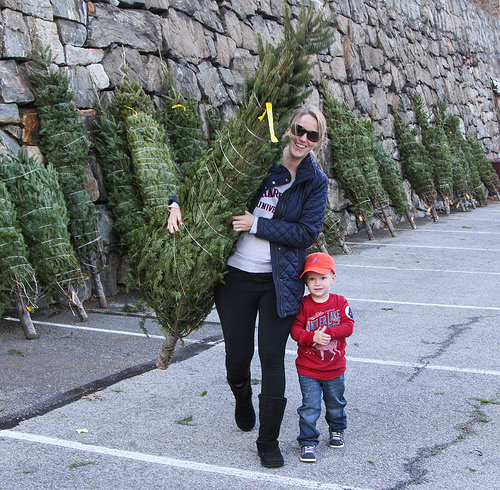<image>
Is there a tree on the woman? Yes. Looking at the image, I can see the tree is positioned on top of the woman, with the woman providing support. Is the tree to the right of the woman? No. The tree is not to the right of the woman. The horizontal positioning shows a different relationship. 